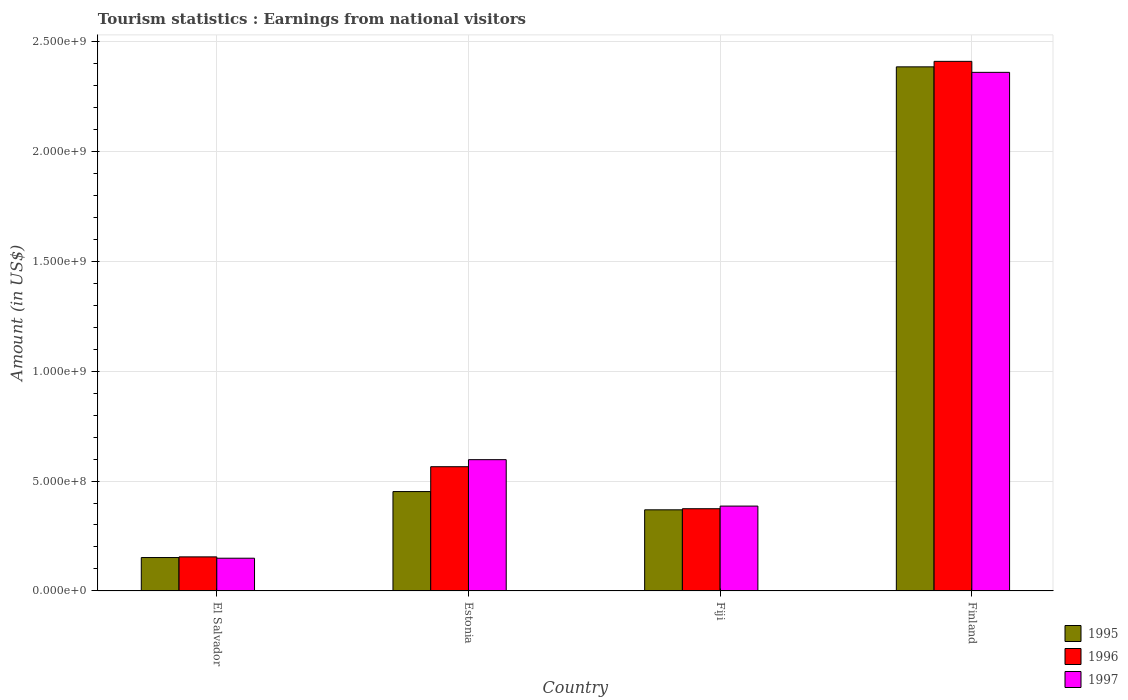Are the number of bars per tick equal to the number of legend labels?
Offer a terse response. Yes. Are the number of bars on each tick of the X-axis equal?
Ensure brevity in your answer.  Yes. How many bars are there on the 3rd tick from the left?
Keep it short and to the point. 3. How many bars are there on the 1st tick from the right?
Offer a terse response. 3. What is the label of the 3rd group of bars from the left?
Make the answer very short. Fiji. In how many cases, is the number of bars for a given country not equal to the number of legend labels?
Offer a very short reply. 0. What is the earnings from national visitors in 1996 in Finland?
Keep it short and to the point. 2.41e+09. Across all countries, what is the maximum earnings from national visitors in 1996?
Keep it short and to the point. 2.41e+09. Across all countries, what is the minimum earnings from national visitors in 1995?
Make the answer very short. 1.52e+08. In which country was the earnings from national visitors in 1995 maximum?
Provide a succinct answer. Finland. In which country was the earnings from national visitors in 1997 minimum?
Ensure brevity in your answer.  El Salvador. What is the total earnings from national visitors in 1997 in the graph?
Offer a very short reply. 3.49e+09. What is the difference between the earnings from national visitors in 1995 in Estonia and that in Fiji?
Offer a very short reply. 8.30e+07. What is the difference between the earnings from national visitors in 1997 in El Salvador and the earnings from national visitors in 1995 in Estonia?
Your response must be concise. -3.03e+08. What is the average earnings from national visitors in 1997 per country?
Give a very brief answer. 8.72e+08. What is the difference between the earnings from national visitors of/in 1997 and earnings from national visitors of/in 1996 in Estonia?
Your answer should be compact. 3.20e+07. In how many countries, is the earnings from national visitors in 1995 greater than 400000000 US$?
Keep it short and to the point. 2. What is the ratio of the earnings from national visitors in 1997 in El Salvador to that in Finland?
Make the answer very short. 0.06. Is the earnings from national visitors in 1996 in El Salvador less than that in Finland?
Give a very brief answer. Yes. Is the difference between the earnings from national visitors in 1997 in El Salvador and Estonia greater than the difference between the earnings from national visitors in 1996 in El Salvador and Estonia?
Ensure brevity in your answer.  No. What is the difference between the highest and the second highest earnings from national visitors in 1995?
Offer a very short reply. 1.93e+09. What is the difference between the highest and the lowest earnings from national visitors in 1997?
Make the answer very short. 2.21e+09. Is the sum of the earnings from national visitors in 1995 in El Salvador and Fiji greater than the maximum earnings from national visitors in 1996 across all countries?
Your answer should be compact. No. What does the 3rd bar from the left in Finland represents?
Offer a very short reply. 1997. How many bars are there?
Your answer should be compact. 12. Are all the bars in the graph horizontal?
Offer a very short reply. No. How many countries are there in the graph?
Offer a very short reply. 4. Does the graph contain grids?
Make the answer very short. Yes. How are the legend labels stacked?
Provide a short and direct response. Vertical. What is the title of the graph?
Give a very brief answer. Tourism statistics : Earnings from national visitors. What is the Amount (in US$) of 1995 in El Salvador?
Ensure brevity in your answer.  1.52e+08. What is the Amount (in US$) of 1996 in El Salvador?
Provide a succinct answer. 1.55e+08. What is the Amount (in US$) of 1997 in El Salvador?
Provide a succinct answer. 1.49e+08. What is the Amount (in US$) in 1995 in Estonia?
Your response must be concise. 4.52e+08. What is the Amount (in US$) of 1996 in Estonia?
Your answer should be very brief. 5.65e+08. What is the Amount (in US$) in 1997 in Estonia?
Provide a short and direct response. 5.97e+08. What is the Amount (in US$) in 1995 in Fiji?
Provide a succinct answer. 3.69e+08. What is the Amount (in US$) of 1996 in Fiji?
Keep it short and to the point. 3.74e+08. What is the Amount (in US$) in 1997 in Fiji?
Offer a very short reply. 3.86e+08. What is the Amount (in US$) in 1995 in Finland?
Make the answer very short. 2.38e+09. What is the Amount (in US$) in 1996 in Finland?
Your response must be concise. 2.41e+09. What is the Amount (in US$) in 1997 in Finland?
Offer a terse response. 2.36e+09. Across all countries, what is the maximum Amount (in US$) of 1995?
Offer a very short reply. 2.38e+09. Across all countries, what is the maximum Amount (in US$) of 1996?
Offer a terse response. 2.41e+09. Across all countries, what is the maximum Amount (in US$) of 1997?
Give a very brief answer. 2.36e+09. Across all countries, what is the minimum Amount (in US$) in 1995?
Ensure brevity in your answer.  1.52e+08. Across all countries, what is the minimum Amount (in US$) of 1996?
Offer a very short reply. 1.55e+08. Across all countries, what is the minimum Amount (in US$) of 1997?
Your answer should be compact. 1.49e+08. What is the total Amount (in US$) in 1995 in the graph?
Your answer should be very brief. 3.36e+09. What is the total Amount (in US$) in 1996 in the graph?
Your answer should be compact. 3.50e+09. What is the total Amount (in US$) in 1997 in the graph?
Give a very brief answer. 3.49e+09. What is the difference between the Amount (in US$) in 1995 in El Salvador and that in Estonia?
Your response must be concise. -3.00e+08. What is the difference between the Amount (in US$) of 1996 in El Salvador and that in Estonia?
Your response must be concise. -4.10e+08. What is the difference between the Amount (in US$) of 1997 in El Salvador and that in Estonia?
Offer a terse response. -4.48e+08. What is the difference between the Amount (in US$) of 1995 in El Salvador and that in Fiji?
Your answer should be very brief. -2.17e+08. What is the difference between the Amount (in US$) in 1996 in El Salvador and that in Fiji?
Provide a short and direct response. -2.19e+08. What is the difference between the Amount (in US$) in 1997 in El Salvador and that in Fiji?
Ensure brevity in your answer.  -2.37e+08. What is the difference between the Amount (in US$) of 1995 in El Salvador and that in Finland?
Your answer should be compact. -2.23e+09. What is the difference between the Amount (in US$) in 1996 in El Salvador and that in Finland?
Give a very brief answer. -2.25e+09. What is the difference between the Amount (in US$) in 1997 in El Salvador and that in Finland?
Offer a terse response. -2.21e+09. What is the difference between the Amount (in US$) of 1995 in Estonia and that in Fiji?
Your response must be concise. 8.30e+07. What is the difference between the Amount (in US$) of 1996 in Estonia and that in Fiji?
Offer a very short reply. 1.91e+08. What is the difference between the Amount (in US$) in 1997 in Estonia and that in Fiji?
Your answer should be very brief. 2.11e+08. What is the difference between the Amount (in US$) of 1995 in Estonia and that in Finland?
Offer a very short reply. -1.93e+09. What is the difference between the Amount (in US$) in 1996 in Estonia and that in Finland?
Provide a succinct answer. -1.84e+09. What is the difference between the Amount (in US$) of 1997 in Estonia and that in Finland?
Ensure brevity in your answer.  -1.76e+09. What is the difference between the Amount (in US$) in 1995 in Fiji and that in Finland?
Give a very brief answer. -2.01e+09. What is the difference between the Amount (in US$) of 1996 in Fiji and that in Finland?
Offer a terse response. -2.03e+09. What is the difference between the Amount (in US$) of 1997 in Fiji and that in Finland?
Your answer should be compact. -1.97e+09. What is the difference between the Amount (in US$) in 1995 in El Salvador and the Amount (in US$) in 1996 in Estonia?
Offer a very short reply. -4.13e+08. What is the difference between the Amount (in US$) in 1995 in El Salvador and the Amount (in US$) in 1997 in Estonia?
Ensure brevity in your answer.  -4.45e+08. What is the difference between the Amount (in US$) of 1996 in El Salvador and the Amount (in US$) of 1997 in Estonia?
Ensure brevity in your answer.  -4.42e+08. What is the difference between the Amount (in US$) in 1995 in El Salvador and the Amount (in US$) in 1996 in Fiji?
Offer a terse response. -2.22e+08. What is the difference between the Amount (in US$) in 1995 in El Salvador and the Amount (in US$) in 1997 in Fiji?
Keep it short and to the point. -2.34e+08. What is the difference between the Amount (in US$) in 1996 in El Salvador and the Amount (in US$) in 1997 in Fiji?
Your answer should be compact. -2.31e+08. What is the difference between the Amount (in US$) of 1995 in El Salvador and the Amount (in US$) of 1996 in Finland?
Give a very brief answer. -2.26e+09. What is the difference between the Amount (in US$) of 1995 in El Salvador and the Amount (in US$) of 1997 in Finland?
Offer a very short reply. -2.21e+09. What is the difference between the Amount (in US$) in 1996 in El Salvador and the Amount (in US$) in 1997 in Finland?
Make the answer very short. -2.20e+09. What is the difference between the Amount (in US$) in 1995 in Estonia and the Amount (in US$) in 1996 in Fiji?
Your response must be concise. 7.80e+07. What is the difference between the Amount (in US$) of 1995 in Estonia and the Amount (in US$) of 1997 in Fiji?
Your response must be concise. 6.60e+07. What is the difference between the Amount (in US$) in 1996 in Estonia and the Amount (in US$) in 1997 in Fiji?
Offer a very short reply. 1.79e+08. What is the difference between the Amount (in US$) of 1995 in Estonia and the Amount (in US$) of 1996 in Finland?
Make the answer very short. -1.96e+09. What is the difference between the Amount (in US$) in 1995 in Estonia and the Amount (in US$) in 1997 in Finland?
Your response must be concise. -1.91e+09. What is the difference between the Amount (in US$) of 1996 in Estonia and the Amount (in US$) of 1997 in Finland?
Provide a succinct answer. -1.79e+09. What is the difference between the Amount (in US$) in 1995 in Fiji and the Amount (in US$) in 1996 in Finland?
Ensure brevity in your answer.  -2.04e+09. What is the difference between the Amount (in US$) of 1995 in Fiji and the Amount (in US$) of 1997 in Finland?
Your response must be concise. -1.99e+09. What is the difference between the Amount (in US$) in 1996 in Fiji and the Amount (in US$) in 1997 in Finland?
Ensure brevity in your answer.  -1.98e+09. What is the average Amount (in US$) of 1995 per country?
Offer a very short reply. 8.39e+08. What is the average Amount (in US$) of 1996 per country?
Your answer should be very brief. 8.76e+08. What is the average Amount (in US$) in 1997 per country?
Provide a short and direct response. 8.72e+08. What is the difference between the Amount (in US$) in 1995 and Amount (in US$) in 1996 in El Salvador?
Your response must be concise. -3.00e+06. What is the difference between the Amount (in US$) in 1995 and Amount (in US$) in 1996 in Estonia?
Offer a very short reply. -1.13e+08. What is the difference between the Amount (in US$) of 1995 and Amount (in US$) of 1997 in Estonia?
Provide a succinct answer. -1.45e+08. What is the difference between the Amount (in US$) in 1996 and Amount (in US$) in 1997 in Estonia?
Your answer should be very brief. -3.20e+07. What is the difference between the Amount (in US$) in 1995 and Amount (in US$) in 1996 in Fiji?
Keep it short and to the point. -5.00e+06. What is the difference between the Amount (in US$) in 1995 and Amount (in US$) in 1997 in Fiji?
Make the answer very short. -1.70e+07. What is the difference between the Amount (in US$) of 1996 and Amount (in US$) of 1997 in Fiji?
Ensure brevity in your answer.  -1.20e+07. What is the difference between the Amount (in US$) in 1995 and Amount (in US$) in 1996 in Finland?
Your answer should be very brief. -2.50e+07. What is the difference between the Amount (in US$) of 1995 and Amount (in US$) of 1997 in Finland?
Offer a very short reply. 2.50e+07. What is the difference between the Amount (in US$) in 1996 and Amount (in US$) in 1997 in Finland?
Give a very brief answer. 5.00e+07. What is the ratio of the Amount (in US$) in 1995 in El Salvador to that in Estonia?
Your response must be concise. 0.34. What is the ratio of the Amount (in US$) of 1996 in El Salvador to that in Estonia?
Ensure brevity in your answer.  0.27. What is the ratio of the Amount (in US$) of 1997 in El Salvador to that in Estonia?
Your answer should be compact. 0.25. What is the ratio of the Amount (in US$) in 1995 in El Salvador to that in Fiji?
Ensure brevity in your answer.  0.41. What is the ratio of the Amount (in US$) in 1996 in El Salvador to that in Fiji?
Offer a very short reply. 0.41. What is the ratio of the Amount (in US$) in 1997 in El Salvador to that in Fiji?
Provide a short and direct response. 0.39. What is the ratio of the Amount (in US$) in 1995 in El Salvador to that in Finland?
Offer a terse response. 0.06. What is the ratio of the Amount (in US$) of 1996 in El Salvador to that in Finland?
Offer a very short reply. 0.06. What is the ratio of the Amount (in US$) of 1997 in El Salvador to that in Finland?
Provide a short and direct response. 0.06. What is the ratio of the Amount (in US$) in 1995 in Estonia to that in Fiji?
Offer a terse response. 1.22. What is the ratio of the Amount (in US$) in 1996 in Estonia to that in Fiji?
Your answer should be compact. 1.51. What is the ratio of the Amount (in US$) in 1997 in Estonia to that in Fiji?
Offer a very short reply. 1.55. What is the ratio of the Amount (in US$) in 1995 in Estonia to that in Finland?
Keep it short and to the point. 0.19. What is the ratio of the Amount (in US$) of 1996 in Estonia to that in Finland?
Your response must be concise. 0.23. What is the ratio of the Amount (in US$) in 1997 in Estonia to that in Finland?
Your answer should be compact. 0.25. What is the ratio of the Amount (in US$) in 1995 in Fiji to that in Finland?
Ensure brevity in your answer.  0.15. What is the ratio of the Amount (in US$) of 1996 in Fiji to that in Finland?
Offer a very short reply. 0.16. What is the ratio of the Amount (in US$) in 1997 in Fiji to that in Finland?
Offer a terse response. 0.16. What is the difference between the highest and the second highest Amount (in US$) of 1995?
Your answer should be compact. 1.93e+09. What is the difference between the highest and the second highest Amount (in US$) of 1996?
Offer a very short reply. 1.84e+09. What is the difference between the highest and the second highest Amount (in US$) of 1997?
Provide a short and direct response. 1.76e+09. What is the difference between the highest and the lowest Amount (in US$) of 1995?
Ensure brevity in your answer.  2.23e+09. What is the difference between the highest and the lowest Amount (in US$) in 1996?
Your answer should be very brief. 2.25e+09. What is the difference between the highest and the lowest Amount (in US$) in 1997?
Make the answer very short. 2.21e+09. 